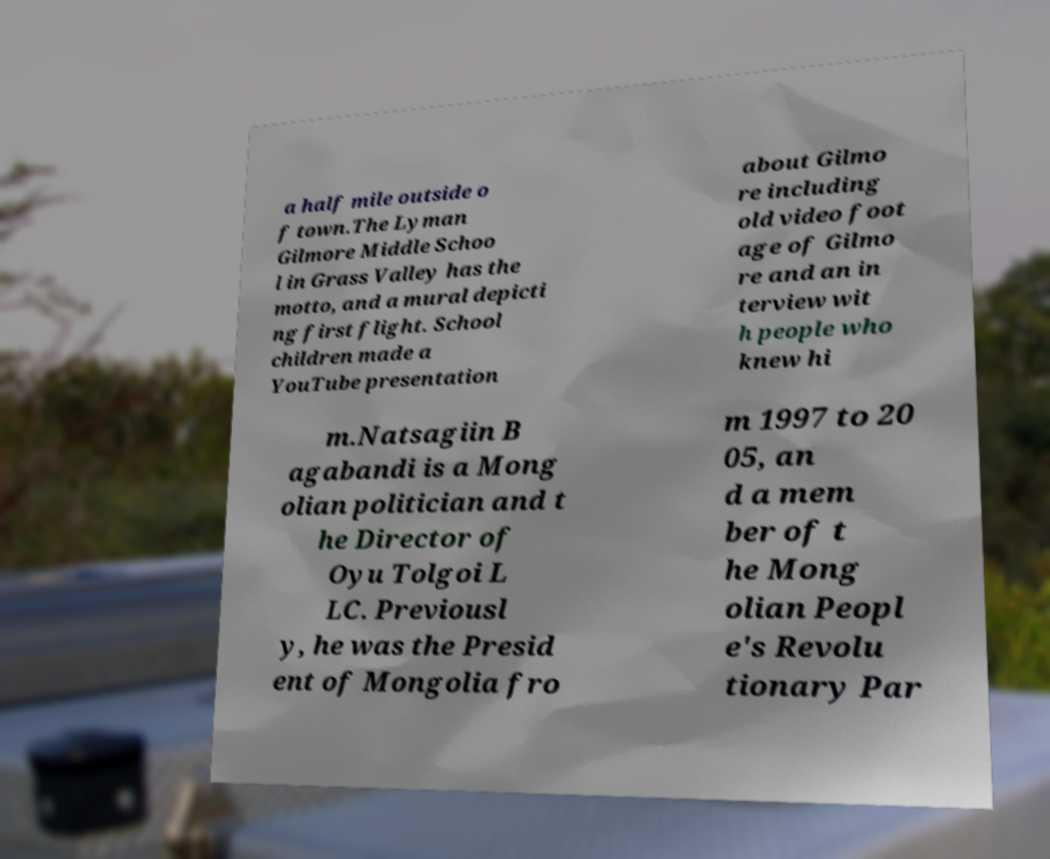Could you extract and type out the text from this image? a half mile outside o f town.The Lyman Gilmore Middle Schoo l in Grass Valley has the motto, and a mural depicti ng first flight. School children made a YouTube presentation about Gilmo re including old video foot age of Gilmo re and an in terview wit h people who knew hi m.Natsagiin B agabandi is a Mong olian politician and t he Director of Oyu Tolgoi L LC. Previousl y, he was the Presid ent of Mongolia fro m 1997 to 20 05, an d a mem ber of t he Mong olian Peopl e's Revolu tionary Par 